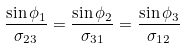<formula> <loc_0><loc_0><loc_500><loc_500>\frac { \sin \phi _ { 1 } } { \sigma _ { 2 3 } } = \frac { \sin \phi _ { 2 } } { \sigma _ { 3 1 } } = \frac { \sin \phi _ { 3 } } { \sigma _ { 1 2 } }</formula> 